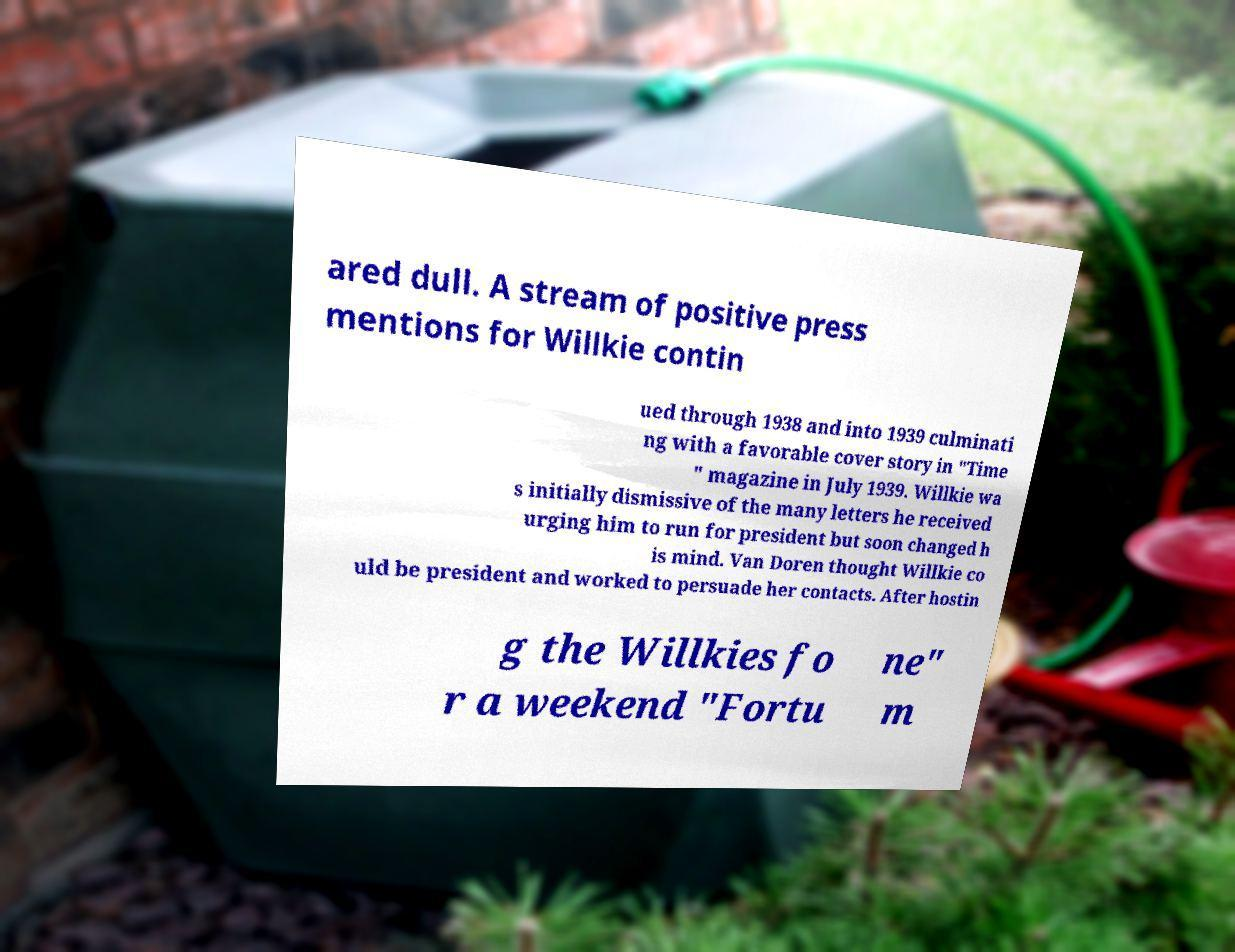Can you read and provide the text displayed in the image?This photo seems to have some interesting text. Can you extract and type it out for me? ared dull. A stream of positive press mentions for Willkie contin ued through 1938 and into 1939 culminati ng with a favorable cover story in "Time " magazine in July 1939. Willkie wa s initially dismissive of the many letters he received urging him to run for president but soon changed h is mind. Van Doren thought Willkie co uld be president and worked to persuade her contacts. After hostin g the Willkies fo r a weekend "Fortu ne" m 